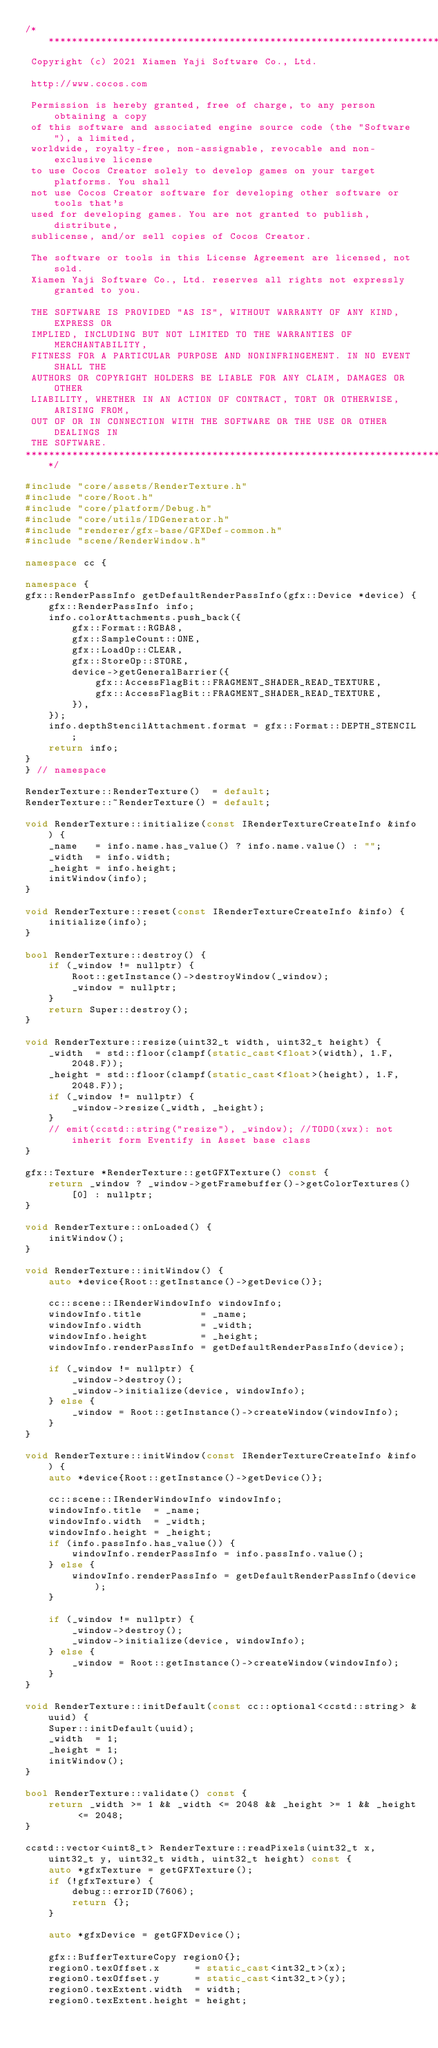<code> <loc_0><loc_0><loc_500><loc_500><_C++_>/****************************************************************************
 Copyright (c) 2021 Xiamen Yaji Software Co., Ltd.

 http://www.cocos.com

 Permission is hereby granted, free of charge, to any person obtaining a copy
 of this software and associated engine source code (the "Software"), a limited,
 worldwide, royalty-free, non-assignable, revocable and non-exclusive license
 to use Cocos Creator solely to develop games on your target platforms. You shall
 not use Cocos Creator software for developing other software or tools that's
 used for developing games. You are not granted to publish, distribute,
 sublicense, and/or sell copies of Cocos Creator.

 The software or tools in this License Agreement are licensed, not sold.
 Xiamen Yaji Software Co., Ltd. reserves all rights not expressly granted to you.

 THE SOFTWARE IS PROVIDED "AS IS", WITHOUT WARRANTY OF ANY KIND, EXPRESS OR
 IMPLIED, INCLUDING BUT NOT LIMITED TO THE WARRANTIES OF MERCHANTABILITY,
 FITNESS FOR A PARTICULAR PURPOSE AND NONINFRINGEMENT. IN NO EVENT SHALL THE
 AUTHORS OR COPYRIGHT HOLDERS BE LIABLE FOR ANY CLAIM, DAMAGES OR OTHER
 LIABILITY, WHETHER IN AN ACTION OF CONTRACT, TORT OR OTHERWISE, ARISING FROM,
 OUT OF OR IN CONNECTION WITH THE SOFTWARE OR THE USE OR OTHER DEALINGS IN
 THE SOFTWARE.
****************************************************************************/

#include "core/assets/RenderTexture.h"
#include "core/Root.h"
#include "core/platform/Debug.h"
#include "core/utils/IDGenerator.h"
#include "renderer/gfx-base/GFXDef-common.h"
#include "scene/RenderWindow.h"

namespace cc {

namespace {
gfx::RenderPassInfo getDefaultRenderPassInfo(gfx::Device *device) {
    gfx::RenderPassInfo info;
    info.colorAttachments.push_back({
        gfx::Format::RGBA8,
        gfx::SampleCount::ONE,
        gfx::LoadOp::CLEAR,
        gfx::StoreOp::STORE,
        device->getGeneralBarrier({
            gfx::AccessFlagBit::FRAGMENT_SHADER_READ_TEXTURE,
            gfx::AccessFlagBit::FRAGMENT_SHADER_READ_TEXTURE,
        }),
    });
    info.depthStencilAttachment.format = gfx::Format::DEPTH_STENCIL;
    return info;
}
} // namespace

RenderTexture::RenderTexture()  = default;
RenderTexture::~RenderTexture() = default;

void RenderTexture::initialize(const IRenderTextureCreateInfo &info) {
    _name   = info.name.has_value() ? info.name.value() : "";
    _width  = info.width;
    _height = info.height;
    initWindow(info);
}

void RenderTexture::reset(const IRenderTextureCreateInfo &info) {
    initialize(info);
}

bool RenderTexture::destroy() {
    if (_window != nullptr) {
        Root::getInstance()->destroyWindow(_window);
        _window = nullptr;
    }
    return Super::destroy();
}

void RenderTexture::resize(uint32_t width, uint32_t height) {
    _width  = std::floor(clampf(static_cast<float>(width), 1.F, 2048.F));
    _height = std::floor(clampf(static_cast<float>(height), 1.F, 2048.F));
    if (_window != nullptr) {
        _window->resize(_width, _height);
    }
    // emit(ccstd::string("resize"), _window); //TODO(xwx): not inherit form Eventify in Asset base class
}

gfx::Texture *RenderTexture::getGFXTexture() const {
    return _window ? _window->getFramebuffer()->getColorTextures()[0] : nullptr;
}

void RenderTexture::onLoaded() {
    initWindow();
}

void RenderTexture::initWindow() {
    auto *device{Root::getInstance()->getDevice()};

    cc::scene::IRenderWindowInfo windowInfo;
    windowInfo.title          = _name;
    windowInfo.width          = _width;
    windowInfo.height         = _height;
    windowInfo.renderPassInfo = getDefaultRenderPassInfo(device);

    if (_window != nullptr) {
        _window->destroy();
        _window->initialize(device, windowInfo);
    } else {
        _window = Root::getInstance()->createWindow(windowInfo);
    }
}

void RenderTexture::initWindow(const IRenderTextureCreateInfo &info) {
    auto *device{Root::getInstance()->getDevice()};

    cc::scene::IRenderWindowInfo windowInfo;
    windowInfo.title  = _name;
    windowInfo.width  = _width;
    windowInfo.height = _height;
    if (info.passInfo.has_value()) {
        windowInfo.renderPassInfo = info.passInfo.value();
    } else {
        windowInfo.renderPassInfo = getDefaultRenderPassInfo(device);
    }

    if (_window != nullptr) {
        _window->destroy();
        _window->initialize(device, windowInfo);
    } else {
        _window = Root::getInstance()->createWindow(windowInfo);
    }
}

void RenderTexture::initDefault(const cc::optional<ccstd::string> &uuid) {
    Super::initDefault(uuid);
    _width  = 1;
    _height = 1;
    initWindow();
}

bool RenderTexture::validate() const {
    return _width >= 1 && _width <= 2048 && _height >= 1 && _height <= 2048;
}

ccstd::vector<uint8_t> RenderTexture::readPixels(uint32_t x, uint32_t y, uint32_t width, uint32_t height) const {
    auto *gfxTexture = getGFXTexture();
    if (!gfxTexture) {
        debug::errorID(7606);
        return {};
    }

    auto *gfxDevice = getGFXDevice();

    gfx::BufferTextureCopy region0{};
    region0.texOffset.x      = static_cast<int32_t>(x);
    region0.texOffset.y      = static_cast<int32_t>(y);
    region0.texExtent.width  = width;
    region0.texExtent.height = height;
</code> 